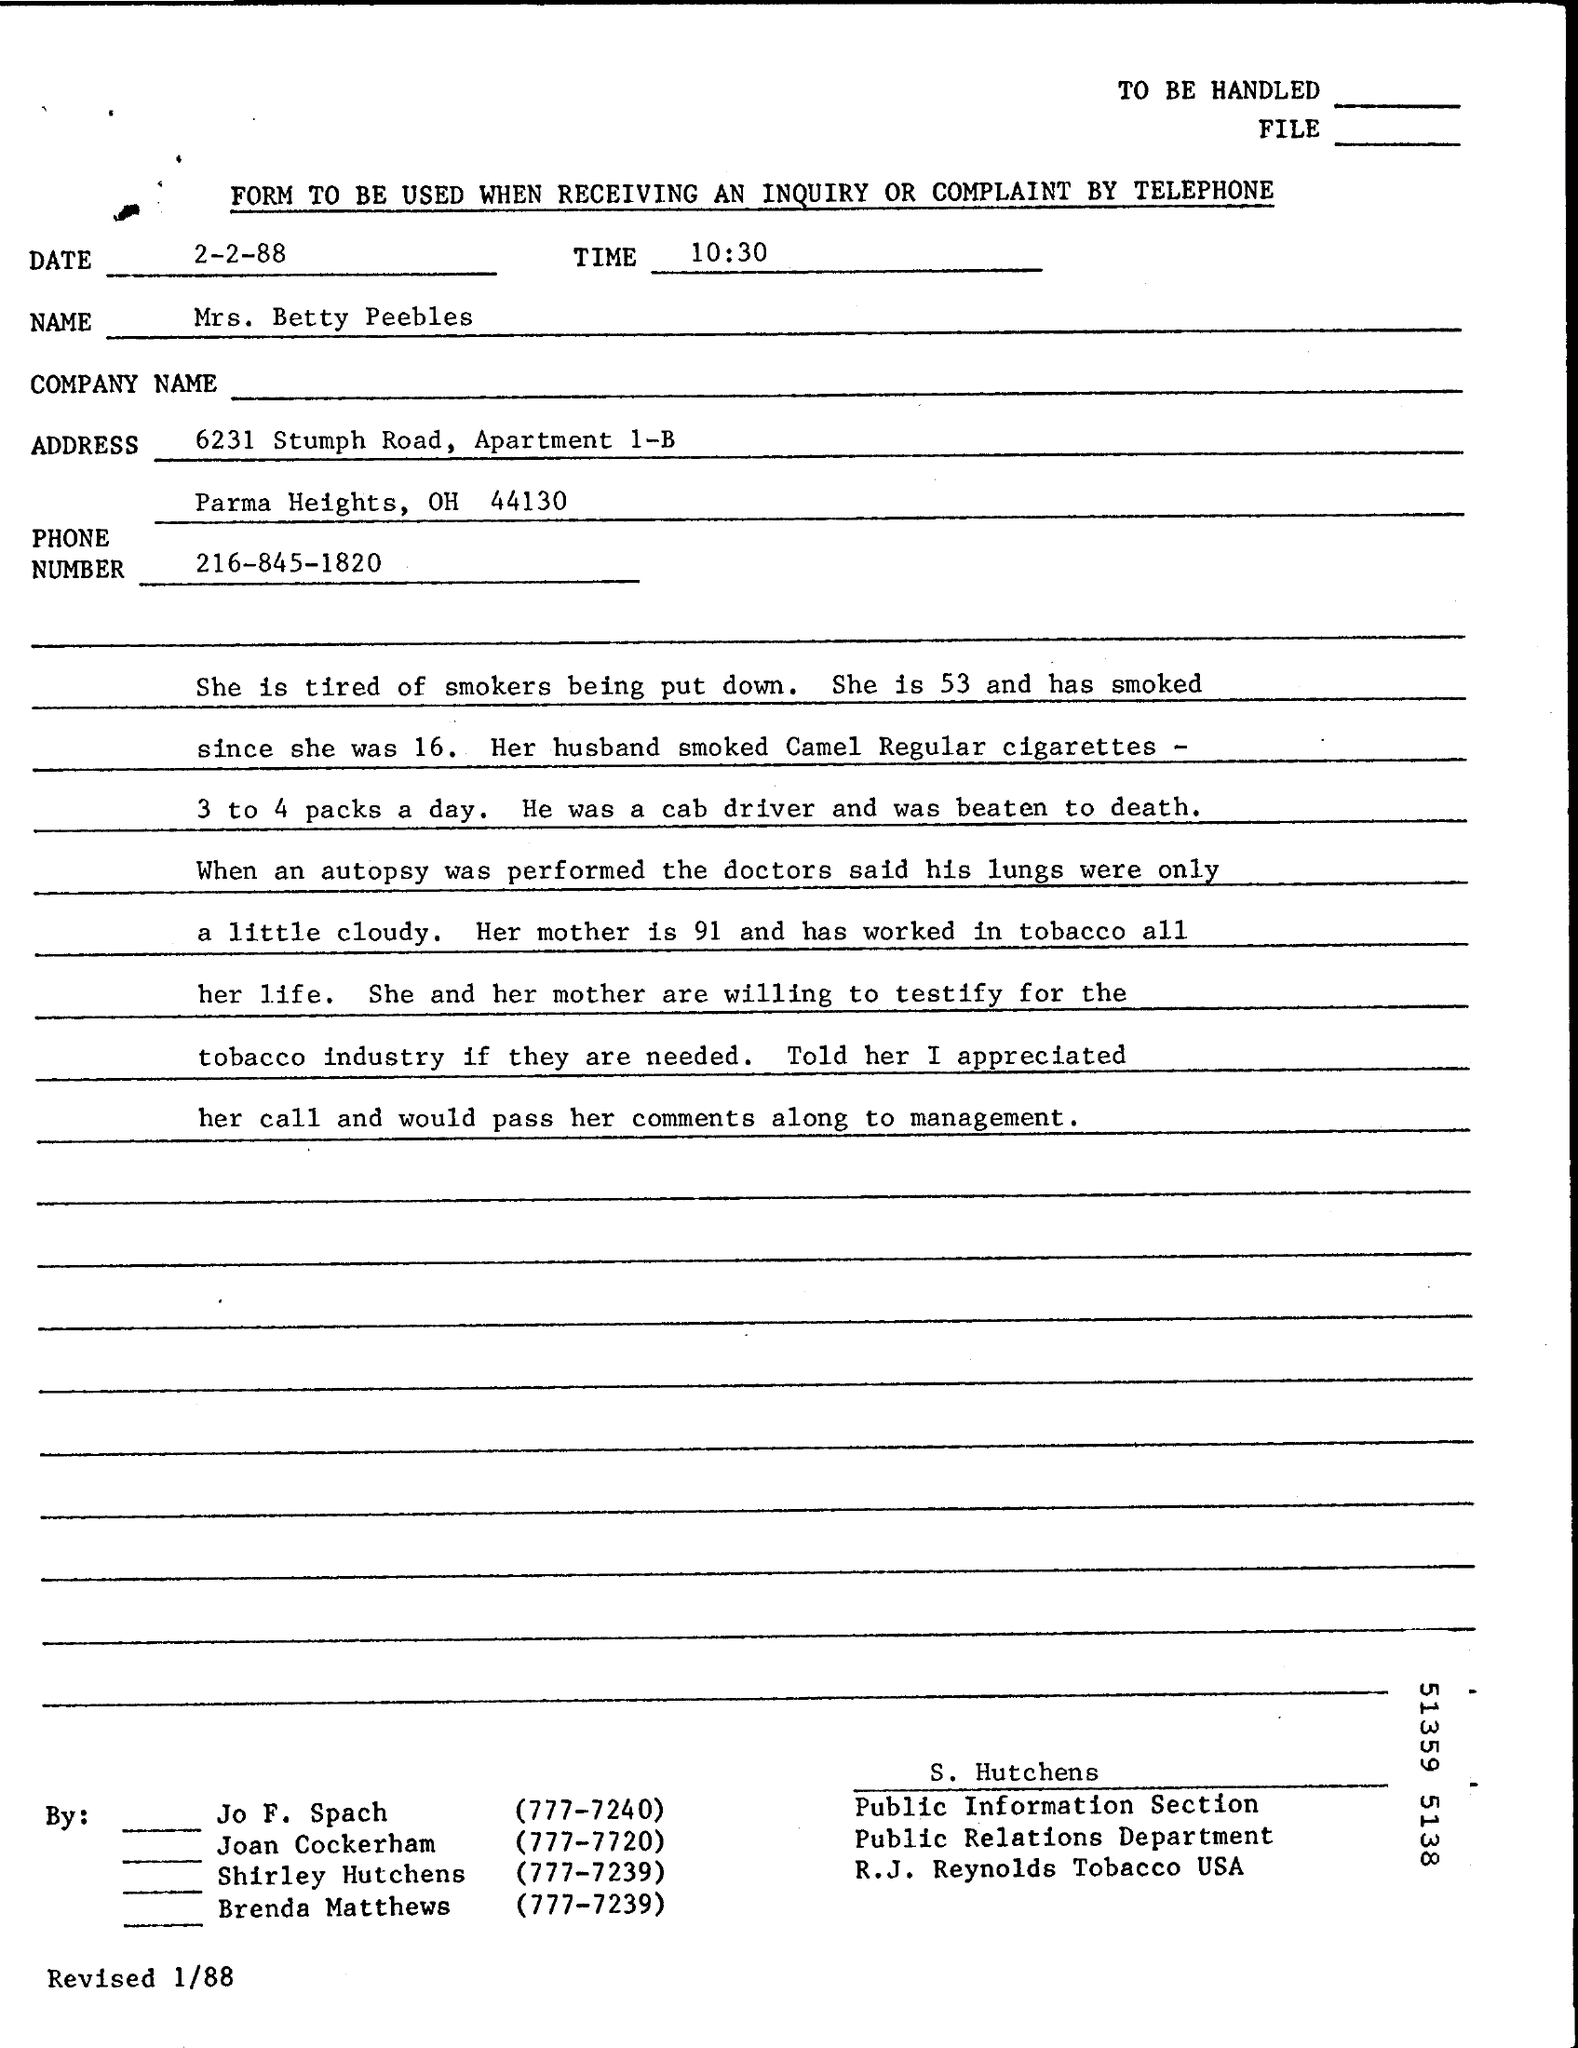What is the Date?
Keep it short and to the point. 2-2-88. What is the Time?
Provide a short and direct response. 10:30. What is the Phone Number?
Offer a very short reply. 216-845-1820. 